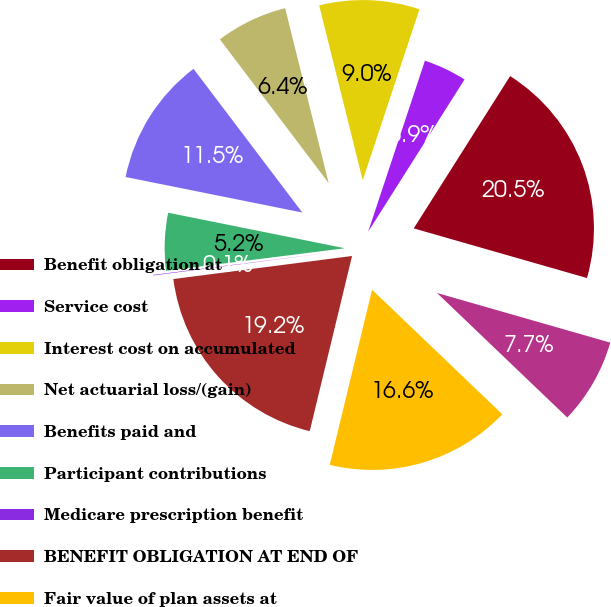Convert chart. <chart><loc_0><loc_0><loc_500><loc_500><pie_chart><fcel>Benefit obligation at<fcel>Service cost<fcel>Interest cost on accumulated<fcel>Net actuarial loss/(gain)<fcel>Benefits paid and<fcel>Participant contributions<fcel>Medicare prescription benefit<fcel>BENEFIT OBLIGATION AT END OF<fcel>Fair value of plan assets at<fcel>Actual return on plan assets<nl><fcel>20.46%<fcel>3.88%<fcel>8.98%<fcel>6.43%<fcel>11.53%<fcel>5.15%<fcel>0.05%<fcel>19.18%<fcel>16.63%<fcel>7.7%<nl></chart> 